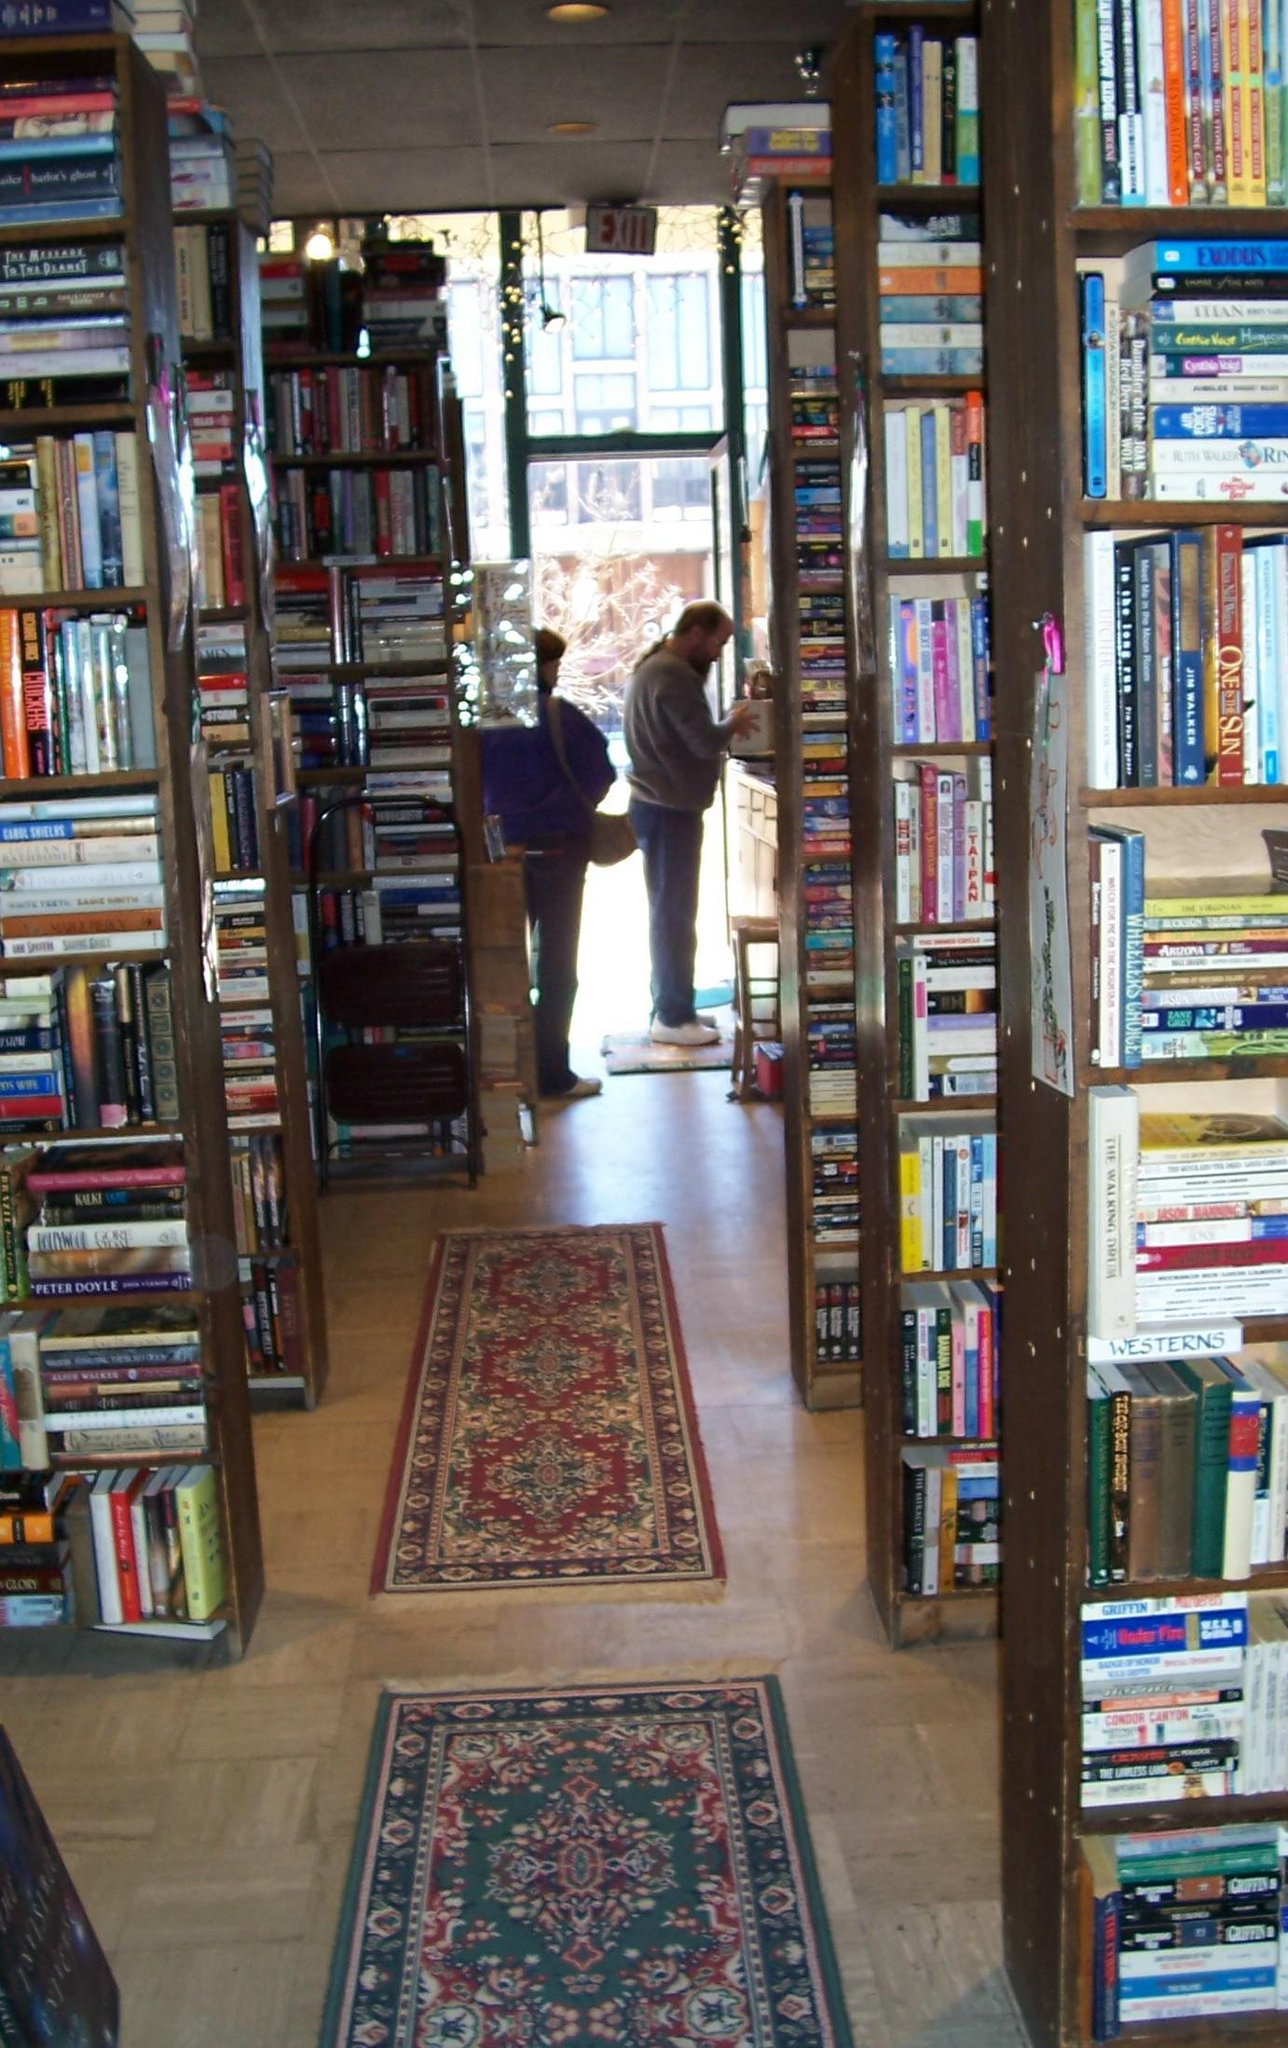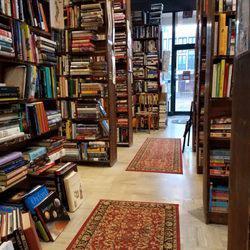The first image is the image on the left, the second image is the image on the right. Examine the images to the left and right. Is the description "In one of the images, people are actively browsing the books." accurate? Answer yes or no. Yes. 